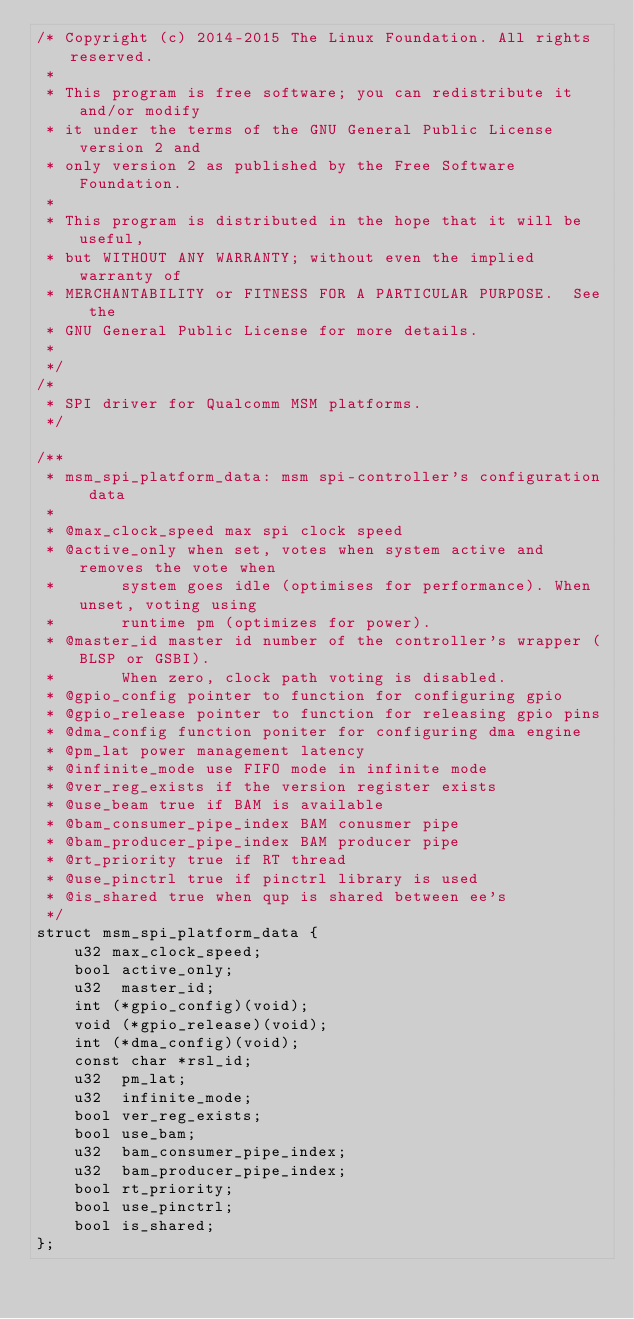Convert code to text. <code><loc_0><loc_0><loc_500><loc_500><_C_>/* Copyright (c) 2014-2015 The Linux Foundation. All rights reserved.
 *
 * This program is free software; you can redistribute it and/or modify
 * it under the terms of the GNU General Public License version 2 and
 * only version 2 as published by the Free Software Foundation.
 *
 * This program is distributed in the hope that it will be useful,
 * but WITHOUT ANY WARRANTY; without even the implied warranty of
 * MERCHANTABILITY or FITNESS FOR A PARTICULAR PURPOSE.  See the
 * GNU General Public License for more details.
 *
 */
/*
 * SPI driver for Qualcomm MSM platforms.
 */

/**
 * msm_spi_platform_data: msm spi-controller's configuration data
 *
 * @max_clock_speed max spi clock speed
 * @active_only when set, votes when system active and removes the vote when
 *       system goes idle (optimises for performance). When unset, voting using
 *       runtime pm (optimizes for power).
 * @master_id master id number of the controller's wrapper (BLSP or GSBI).
 *       When zero, clock path voting is disabled.
 * @gpio_config pointer to function for configuring gpio
 * @gpio_release pointer to function for releasing gpio pins
 * @dma_config function poniter for configuring dma engine
 * @pm_lat power management latency
 * @infinite_mode use FIFO mode in infinite mode
 * @ver_reg_exists if the version register exists
 * @use_beam true if BAM is available
 * @bam_consumer_pipe_index BAM conusmer pipe
 * @bam_producer_pipe_index BAM producer pipe
 * @rt_priority true if RT thread
 * @use_pinctrl true if pinctrl library is used
 * @is_shared true when qup is shared between ee's
 */
struct msm_spi_platform_data {
	u32 max_clock_speed;
	bool active_only;
	u32  master_id;
	int (*gpio_config)(void);
	void (*gpio_release)(void);
	int (*dma_config)(void);
	const char *rsl_id;
	u32  pm_lat;
	u32  infinite_mode;
	bool ver_reg_exists;
	bool use_bam;
	u32  bam_consumer_pipe_index;
	u32  bam_producer_pipe_index;
	bool rt_priority;
	bool use_pinctrl;
	bool is_shared;
};
</code> 